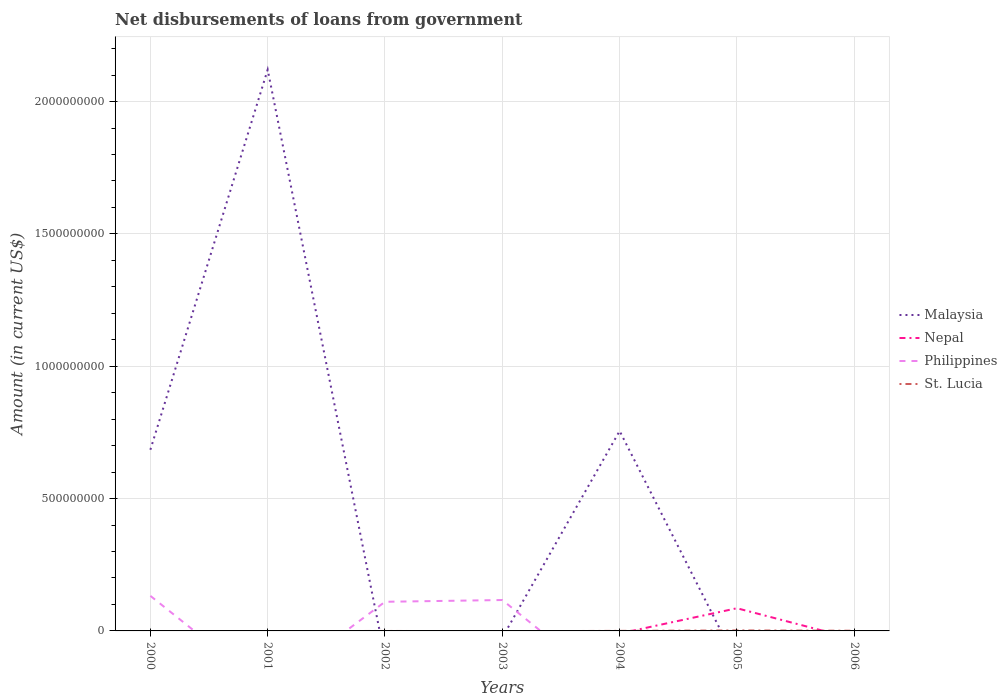How many different coloured lines are there?
Offer a terse response. 4. Across all years, what is the maximum amount of loan disbursed from government in Philippines?
Give a very brief answer. 0. What is the total amount of loan disbursed from government in St. Lucia in the graph?
Provide a succinct answer. -5.12e+05. What is the difference between the highest and the second highest amount of loan disbursed from government in Nepal?
Your response must be concise. 8.57e+07. What is the difference between the highest and the lowest amount of loan disbursed from government in Philippines?
Ensure brevity in your answer.  3. Is the amount of loan disbursed from government in Philippines strictly greater than the amount of loan disbursed from government in Malaysia over the years?
Your answer should be very brief. No. How many lines are there?
Offer a very short reply. 4. Are the values on the major ticks of Y-axis written in scientific E-notation?
Make the answer very short. No. Does the graph contain any zero values?
Provide a short and direct response. Yes. How many legend labels are there?
Your answer should be compact. 4. What is the title of the graph?
Your answer should be compact. Net disbursements of loans from government. Does "Solomon Islands" appear as one of the legend labels in the graph?
Offer a terse response. No. What is the label or title of the Y-axis?
Give a very brief answer. Amount (in current US$). What is the Amount (in current US$) of Malaysia in 2000?
Ensure brevity in your answer.  6.84e+08. What is the Amount (in current US$) in Philippines in 2000?
Offer a very short reply. 1.32e+08. What is the Amount (in current US$) in Malaysia in 2001?
Keep it short and to the point. 2.12e+09. What is the Amount (in current US$) in Nepal in 2001?
Provide a short and direct response. 0. What is the Amount (in current US$) of Philippines in 2001?
Ensure brevity in your answer.  0. What is the Amount (in current US$) in Malaysia in 2002?
Make the answer very short. 0. What is the Amount (in current US$) of Nepal in 2002?
Provide a succinct answer. 0. What is the Amount (in current US$) of Philippines in 2002?
Keep it short and to the point. 1.10e+08. What is the Amount (in current US$) of Philippines in 2003?
Offer a terse response. 1.17e+08. What is the Amount (in current US$) in St. Lucia in 2003?
Offer a very short reply. 0. What is the Amount (in current US$) of Malaysia in 2004?
Make the answer very short. 7.55e+08. What is the Amount (in current US$) of St. Lucia in 2004?
Your answer should be compact. 2.13e+05. What is the Amount (in current US$) of Nepal in 2005?
Your answer should be compact. 8.57e+07. What is the Amount (in current US$) in St. Lucia in 2005?
Offer a terse response. 1.85e+06. What is the Amount (in current US$) of Malaysia in 2006?
Offer a very short reply. 0. What is the Amount (in current US$) in Nepal in 2006?
Your answer should be compact. 0. What is the Amount (in current US$) of St. Lucia in 2006?
Offer a terse response. 7.25e+05. Across all years, what is the maximum Amount (in current US$) in Malaysia?
Provide a short and direct response. 2.12e+09. Across all years, what is the maximum Amount (in current US$) of Nepal?
Offer a terse response. 8.57e+07. Across all years, what is the maximum Amount (in current US$) in Philippines?
Offer a terse response. 1.32e+08. Across all years, what is the maximum Amount (in current US$) in St. Lucia?
Your answer should be compact. 1.85e+06. Across all years, what is the minimum Amount (in current US$) of Philippines?
Your answer should be very brief. 0. Across all years, what is the minimum Amount (in current US$) in St. Lucia?
Your answer should be compact. 0. What is the total Amount (in current US$) in Malaysia in the graph?
Offer a very short reply. 3.56e+09. What is the total Amount (in current US$) in Nepal in the graph?
Your answer should be compact. 8.57e+07. What is the total Amount (in current US$) of Philippines in the graph?
Give a very brief answer. 3.59e+08. What is the total Amount (in current US$) of St. Lucia in the graph?
Your answer should be very brief. 2.79e+06. What is the difference between the Amount (in current US$) in Malaysia in 2000 and that in 2001?
Your answer should be compact. -1.44e+09. What is the difference between the Amount (in current US$) in Philippines in 2000 and that in 2002?
Give a very brief answer. 2.24e+07. What is the difference between the Amount (in current US$) in Philippines in 2000 and that in 2003?
Keep it short and to the point. 1.57e+07. What is the difference between the Amount (in current US$) in Malaysia in 2000 and that in 2004?
Keep it short and to the point. -7.10e+07. What is the difference between the Amount (in current US$) in Malaysia in 2001 and that in 2004?
Make the answer very short. 1.37e+09. What is the difference between the Amount (in current US$) of Philippines in 2002 and that in 2003?
Your answer should be very brief. -6.67e+06. What is the difference between the Amount (in current US$) in St. Lucia in 2004 and that in 2005?
Your response must be concise. -1.64e+06. What is the difference between the Amount (in current US$) of St. Lucia in 2004 and that in 2006?
Give a very brief answer. -5.12e+05. What is the difference between the Amount (in current US$) of St. Lucia in 2005 and that in 2006?
Your answer should be compact. 1.13e+06. What is the difference between the Amount (in current US$) of Malaysia in 2000 and the Amount (in current US$) of Philippines in 2002?
Your response must be concise. 5.74e+08. What is the difference between the Amount (in current US$) of Malaysia in 2000 and the Amount (in current US$) of Philippines in 2003?
Provide a succinct answer. 5.68e+08. What is the difference between the Amount (in current US$) in Malaysia in 2000 and the Amount (in current US$) in St. Lucia in 2004?
Give a very brief answer. 6.84e+08. What is the difference between the Amount (in current US$) in Philippines in 2000 and the Amount (in current US$) in St. Lucia in 2004?
Keep it short and to the point. 1.32e+08. What is the difference between the Amount (in current US$) in Malaysia in 2000 and the Amount (in current US$) in Nepal in 2005?
Offer a terse response. 5.99e+08. What is the difference between the Amount (in current US$) in Malaysia in 2000 and the Amount (in current US$) in St. Lucia in 2005?
Provide a short and direct response. 6.83e+08. What is the difference between the Amount (in current US$) of Philippines in 2000 and the Amount (in current US$) of St. Lucia in 2005?
Offer a terse response. 1.31e+08. What is the difference between the Amount (in current US$) of Malaysia in 2000 and the Amount (in current US$) of St. Lucia in 2006?
Ensure brevity in your answer.  6.84e+08. What is the difference between the Amount (in current US$) in Philippines in 2000 and the Amount (in current US$) in St. Lucia in 2006?
Your answer should be compact. 1.32e+08. What is the difference between the Amount (in current US$) in Malaysia in 2001 and the Amount (in current US$) in Philippines in 2002?
Keep it short and to the point. 2.01e+09. What is the difference between the Amount (in current US$) of Malaysia in 2001 and the Amount (in current US$) of Philippines in 2003?
Give a very brief answer. 2.00e+09. What is the difference between the Amount (in current US$) in Malaysia in 2001 and the Amount (in current US$) in St. Lucia in 2004?
Your answer should be very brief. 2.12e+09. What is the difference between the Amount (in current US$) in Malaysia in 2001 and the Amount (in current US$) in Nepal in 2005?
Give a very brief answer. 2.03e+09. What is the difference between the Amount (in current US$) in Malaysia in 2001 and the Amount (in current US$) in St. Lucia in 2005?
Make the answer very short. 2.12e+09. What is the difference between the Amount (in current US$) of Malaysia in 2001 and the Amount (in current US$) of St. Lucia in 2006?
Offer a very short reply. 2.12e+09. What is the difference between the Amount (in current US$) in Philippines in 2002 and the Amount (in current US$) in St. Lucia in 2004?
Your answer should be very brief. 1.10e+08. What is the difference between the Amount (in current US$) in Philippines in 2002 and the Amount (in current US$) in St. Lucia in 2005?
Offer a very short reply. 1.08e+08. What is the difference between the Amount (in current US$) of Philippines in 2002 and the Amount (in current US$) of St. Lucia in 2006?
Ensure brevity in your answer.  1.09e+08. What is the difference between the Amount (in current US$) in Philippines in 2003 and the Amount (in current US$) in St. Lucia in 2004?
Offer a terse response. 1.17e+08. What is the difference between the Amount (in current US$) of Philippines in 2003 and the Amount (in current US$) of St. Lucia in 2005?
Keep it short and to the point. 1.15e+08. What is the difference between the Amount (in current US$) in Philippines in 2003 and the Amount (in current US$) in St. Lucia in 2006?
Ensure brevity in your answer.  1.16e+08. What is the difference between the Amount (in current US$) of Malaysia in 2004 and the Amount (in current US$) of Nepal in 2005?
Your response must be concise. 6.70e+08. What is the difference between the Amount (in current US$) in Malaysia in 2004 and the Amount (in current US$) in St. Lucia in 2005?
Your answer should be compact. 7.54e+08. What is the difference between the Amount (in current US$) in Malaysia in 2004 and the Amount (in current US$) in St. Lucia in 2006?
Your response must be concise. 7.55e+08. What is the difference between the Amount (in current US$) in Nepal in 2005 and the Amount (in current US$) in St. Lucia in 2006?
Provide a short and direct response. 8.50e+07. What is the average Amount (in current US$) in Malaysia per year?
Offer a terse response. 5.09e+08. What is the average Amount (in current US$) in Nepal per year?
Ensure brevity in your answer.  1.22e+07. What is the average Amount (in current US$) of Philippines per year?
Provide a succinct answer. 5.13e+07. What is the average Amount (in current US$) of St. Lucia per year?
Keep it short and to the point. 3.99e+05. In the year 2000, what is the difference between the Amount (in current US$) of Malaysia and Amount (in current US$) of Philippines?
Your response must be concise. 5.52e+08. In the year 2004, what is the difference between the Amount (in current US$) of Malaysia and Amount (in current US$) of St. Lucia?
Offer a very short reply. 7.55e+08. In the year 2005, what is the difference between the Amount (in current US$) of Nepal and Amount (in current US$) of St. Lucia?
Your response must be concise. 8.39e+07. What is the ratio of the Amount (in current US$) in Malaysia in 2000 to that in 2001?
Make the answer very short. 0.32. What is the ratio of the Amount (in current US$) in Philippines in 2000 to that in 2002?
Keep it short and to the point. 1.2. What is the ratio of the Amount (in current US$) of Philippines in 2000 to that in 2003?
Your response must be concise. 1.13. What is the ratio of the Amount (in current US$) in Malaysia in 2000 to that in 2004?
Offer a terse response. 0.91. What is the ratio of the Amount (in current US$) in Malaysia in 2001 to that in 2004?
Keep it short and to the point. 2.81. What is the ratio of the Amount (in current US$) in Philippines in 2002 to that in 2003?
Keep it short and to the point. 0.94. What is the ratio of the Amount (in current US$) in St. Lucia in 2004 to that in 2005?
Your answer should be compact. 0.11. What is the ratio of the Amount (in current US$) in St. Lucia in 2004 to that in 2006?
Your response must be concise. 0.29. What is the ratio of the Amount (in current US$) in St. Lucia in 2005 to that in 2006?
Ensure brevity in your answer.  2.56. What is the difference between the highest and the second highest Amount (in current US$) in Malaysia?
Your response must be concise. 1.37e+09. What is the difference between the highest and the second highest Amount (in current US$) of Philippines?
Your answer should be compact. 1.57e+07. What is the difference between the highest and the second highest Amount (in current US$) of St. Lucia?
Keep it short and to the point. 1.13e+06. What is the difference between the highest and the lowest Amount (in current US$) of Malaysia?
Give a very brief answer. 2.12e+09. What is the difference between the highest and the lowest Amount (in current US$) of Nepal?
Make the answer very short. 8.57e+07. What is the difference between the highest and the lowest Amount (in current US$) in Philippines?
Ensure brevity in your answer.  1.32e+08. What is the difference between the highest and the lowest Amount (in current US$) in St. Lucia?
Offer a terse response. 1.85e+06. 